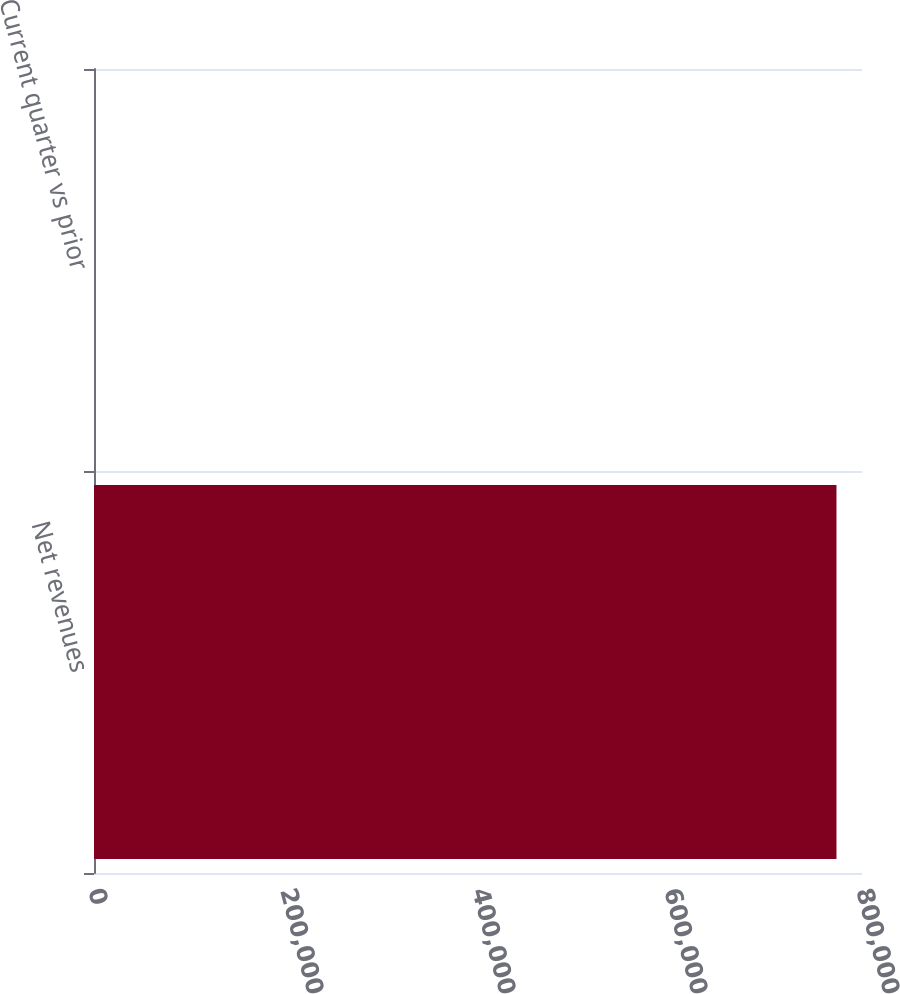Convert chart. <chart><loc_0><loc_0><loc_500><loc_500><bar_chart><fcel>Net revenues<fcel>Current quarter vs prior<nl><fcel>773412<fcel>2<nl></chart> 